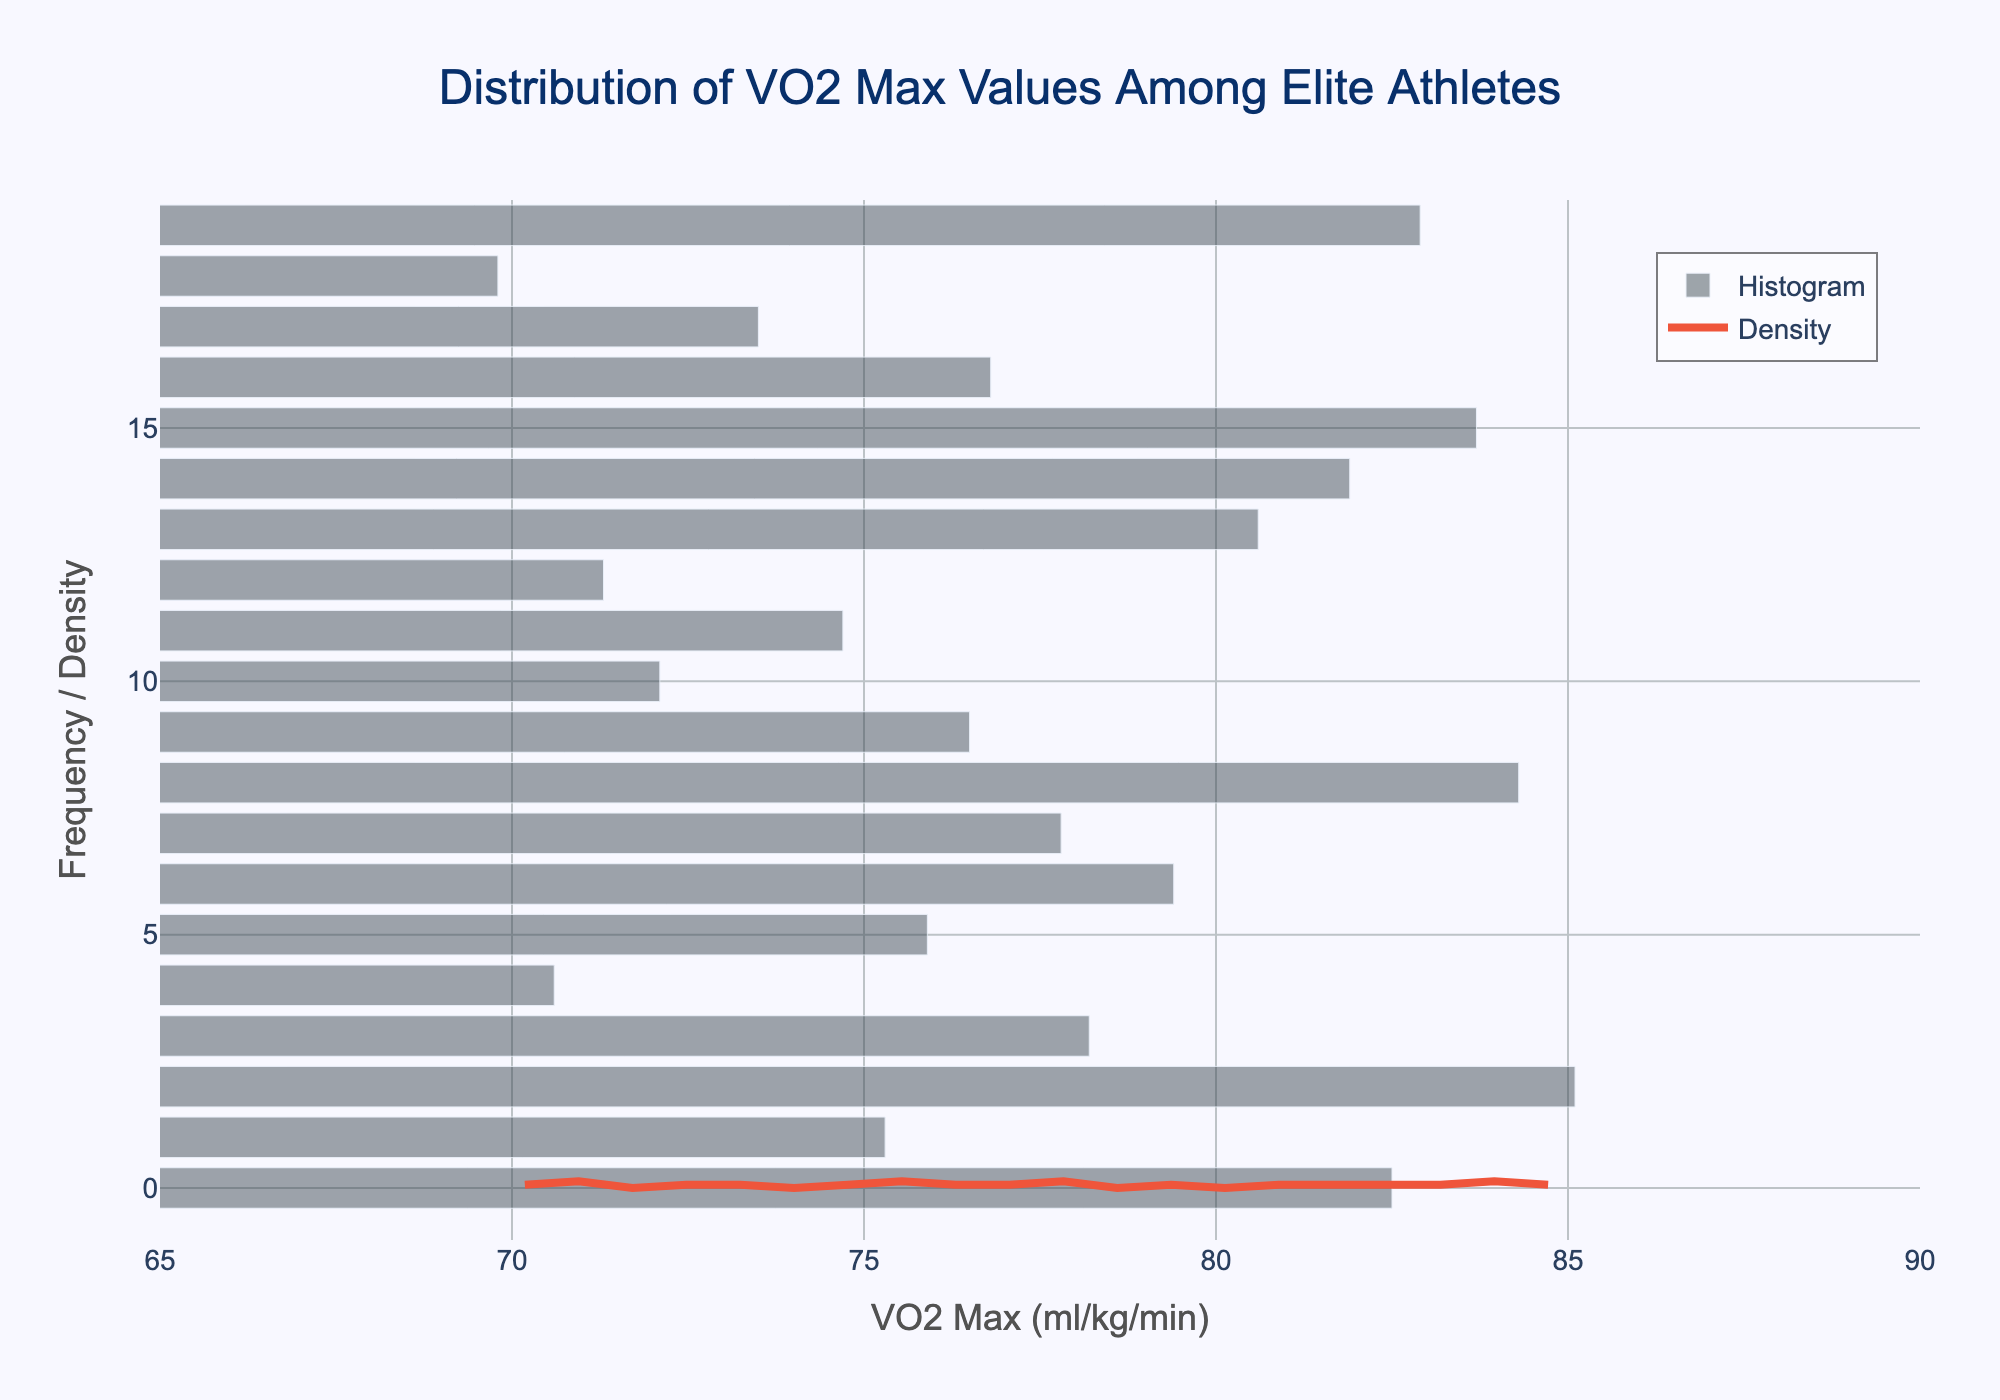what is the title of the figure? The title of the figure is found at the top and usually in larger, bolder text. It helps viewers understand the main subject of the figure. The title is "Distribution of VO2 Max Values Among Elite Athletes".
Answer: Distribution of VO2 Max Values Among Elite Athletes what does the x-axis represent? The x-axis is labeled and explains what values are being displayed horizontally in the figure. In this case, the x-axis represents VO2 Max values in ml/kg/min.
Answer: VO2 Max (ml/kg/min) what are the two types of plots used in the figure? There are two distinct visual elements in the figure: a histogram (represented by bars) and a Kernel Density Estimate (KDE) curve (represented by a line).
Answer: Histogram and Density Curve what is the range of VO2 max values shown in the figure? The x-axis of the figure shows the range of VO2 Max values being measured. These values range from 65 to 90 ml/kg/min.
Answer: 65 to 90 ml/kg/min which discipline likely has the highest VO2 max among those listed? The histogram shows a peak near the higher end of the VO2 Max values. The discipline with the highest VO2 Max value is likely cross-country skiing, with a value of 85.1 ml/kg/min, near the peak of the KDE.
Answer: Cross-country skiing how does the density curve complement the histogram? The density curve (KDE) smooths out the frequency of the VO2 Max values, providing a continuous estimate of the probability density function. This helps identify the general distribution pattern without being affected by the bin width of the histogram.
Answer: It smooths the distribution pattern of the data which VO2 max value appears to be the most common among elite athletes? The KDE curve's peak indicates the most common values. The VO2 Max value around 80 ml/kg/min appears to be the most common among elite athletes.
Answer: Around 80 ml/kg/min how do the VO2 max values compare between swimming and cross-country running? By examining the histogram bars, you can see that swimmers have a lower VO2 Max value of 70.6 ml/kg/min, while cross-country runners have a higher value of 81.9 ml/kg/min.
Answer: Swimming has 70.6; cross-country running has 81.9 what is the approximate median value of the VO2 max distribution? By looking at the histogram and KDE curve, the median value falls where roughly half of the data lies on either side. The median VO2 Max value appears around 77-78 ml/kg/min.
Answer: 77-78 ml/kg/min are there any outliers in the VO2 max distribution? Outliers would be noticeably far from the rest of the data points. Based on the histogram and KDE, there don't appear to be any extreme outliers in the 65 to 90 ml/kg/min range.
Answer: No significant outliers 